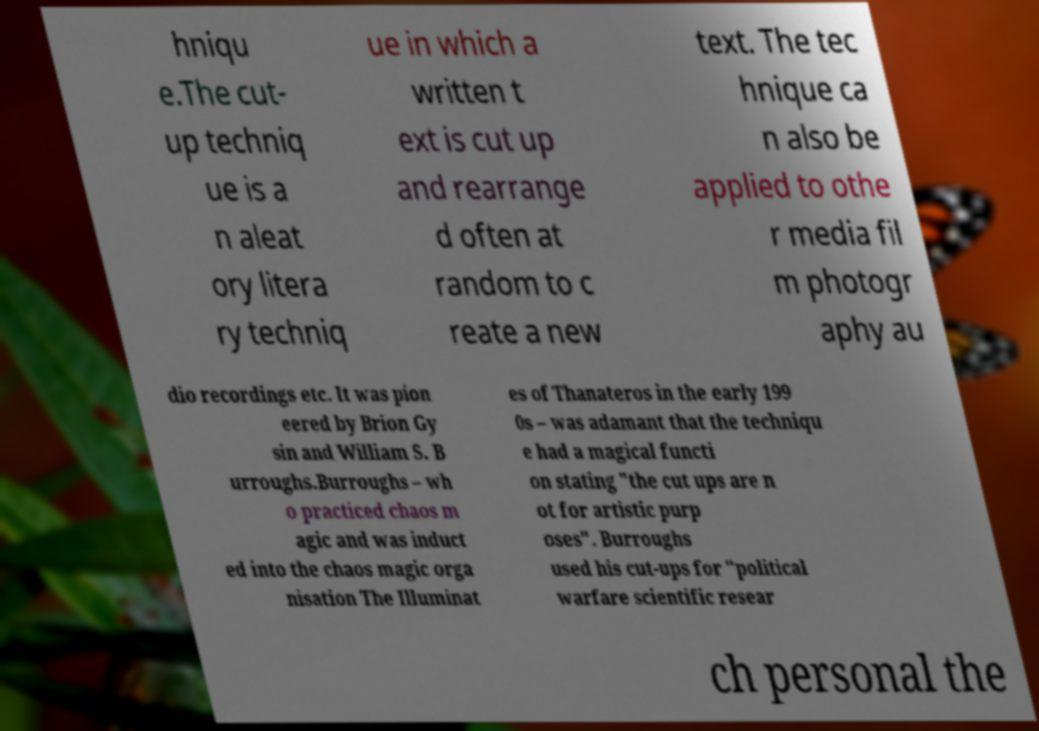There's text embedded in this image that I need extracted. Can you transcribe it verbatim? hniqu e.The cut- up techniq ue is a n aleat ory litera ry techniq ue in which a written t ext is cut up and rearrange d often at random to c reate a new text. The tec hnique ca n also be applied to othe r media fil m photogr aphy au dio recordings etc. It was pion eered by Brion Gy sin and William S. B urroughs.Burroughs – wh o practiced chaos m agic and was induct ed into the chaos magic orga nisation The Illuminat es of Thanateros in the early 199 0s – was adamant that the techniqu e had a magical functi on stating "the cut ups are n ot for artistic purp oses". Burroughs used his cut-ups for "political warfare scientific resear ch personal the 